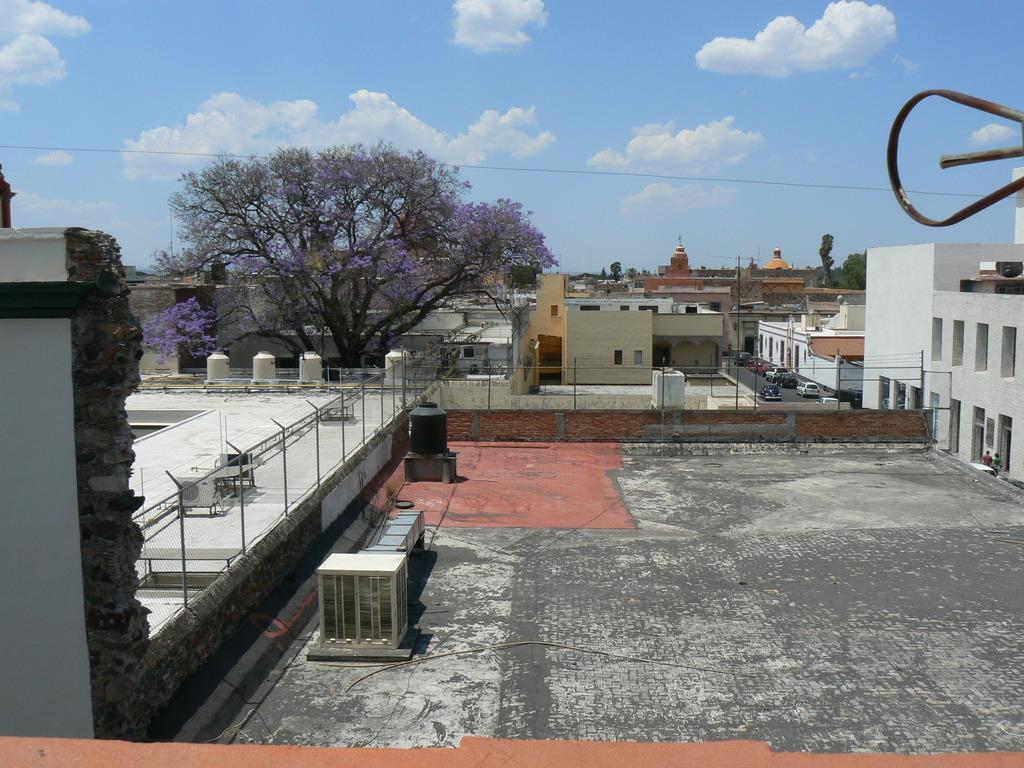Describe this image in one or two sentences. In this image there are buildings, railings, cloudy sky, trees, people, vehicles and objects. Vehicles are on the road. 